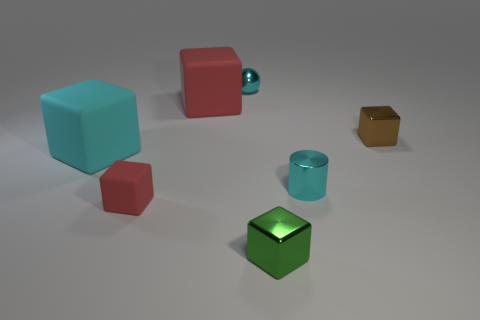Is the color of the cube in front of the tiny red matte block the same as the tiny sphere?
Keep it short and to the point. No. There is a big object that is on the right side of the cyan block; is its color the same as the metallic block to the left of the tiny brown block?
Ensure brevity in your answer.  No. Is there a tiny red cube made of the same material as the green object?
Make the answer very short. No. How many gray things are either tiny balls or metal things?
Offer a terse response. 0. Are there more small metallic spheres that are on the right side of the tiny brown block than small green things?
Provide a short and direct response. No. Is the cyan matte block the same size as the sphere?
Make the answer very short. No. What is the color of the other big block that is made of the same material as the big red cube?
Offer a terse response. Cyan. What is the shape of the metal object that is the same color as the tiny cylinder?
Make the answer very short. Sphere. Is the number of red things to the left of the large red thing the same as the number of tiny matte cubes to the left of the cyan cube?
Provide a short and direct response. No. There is a small cyan thing behind the brown shiny object that is behind the big cyan matte block; what is its shape?
Keep it short and to the point. Sphere. 